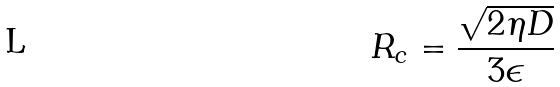Convert formula to latex. <formula><loc_0><loc_0><loc_500><loc_500>R _ { c } = \frac { \sqrt { 2 \eta D } } { 3 \epsilon }</formula> 